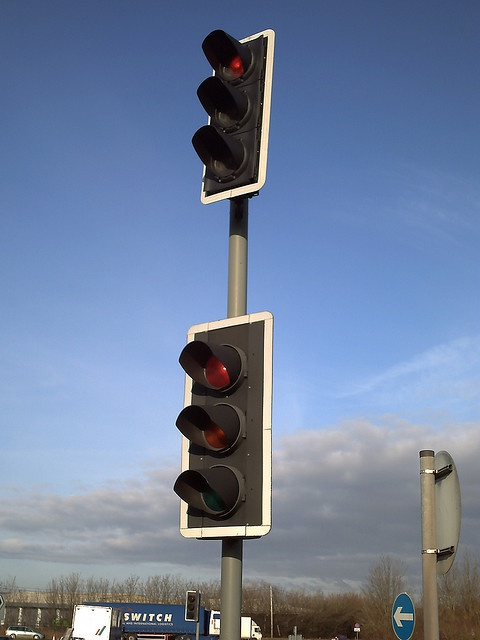Describe the objects in this image and their specific colors. I can see traffic light in blue, black, and beige tones, traffic light in blue, black, maroon, and gray tones, truck in blue, darkblue, black, gray, and beige tones, truck in blue, white, darkgray, gray, and black tones, and traffic light in blue, black, and gray tones in this image. 